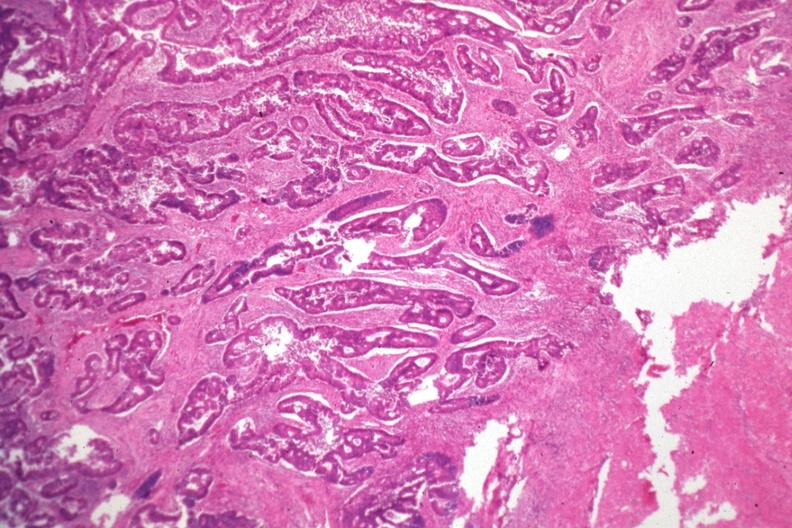what does this image show?
Answer the question using a single word or phrase. Typical infiltrating adenocarcinoma 